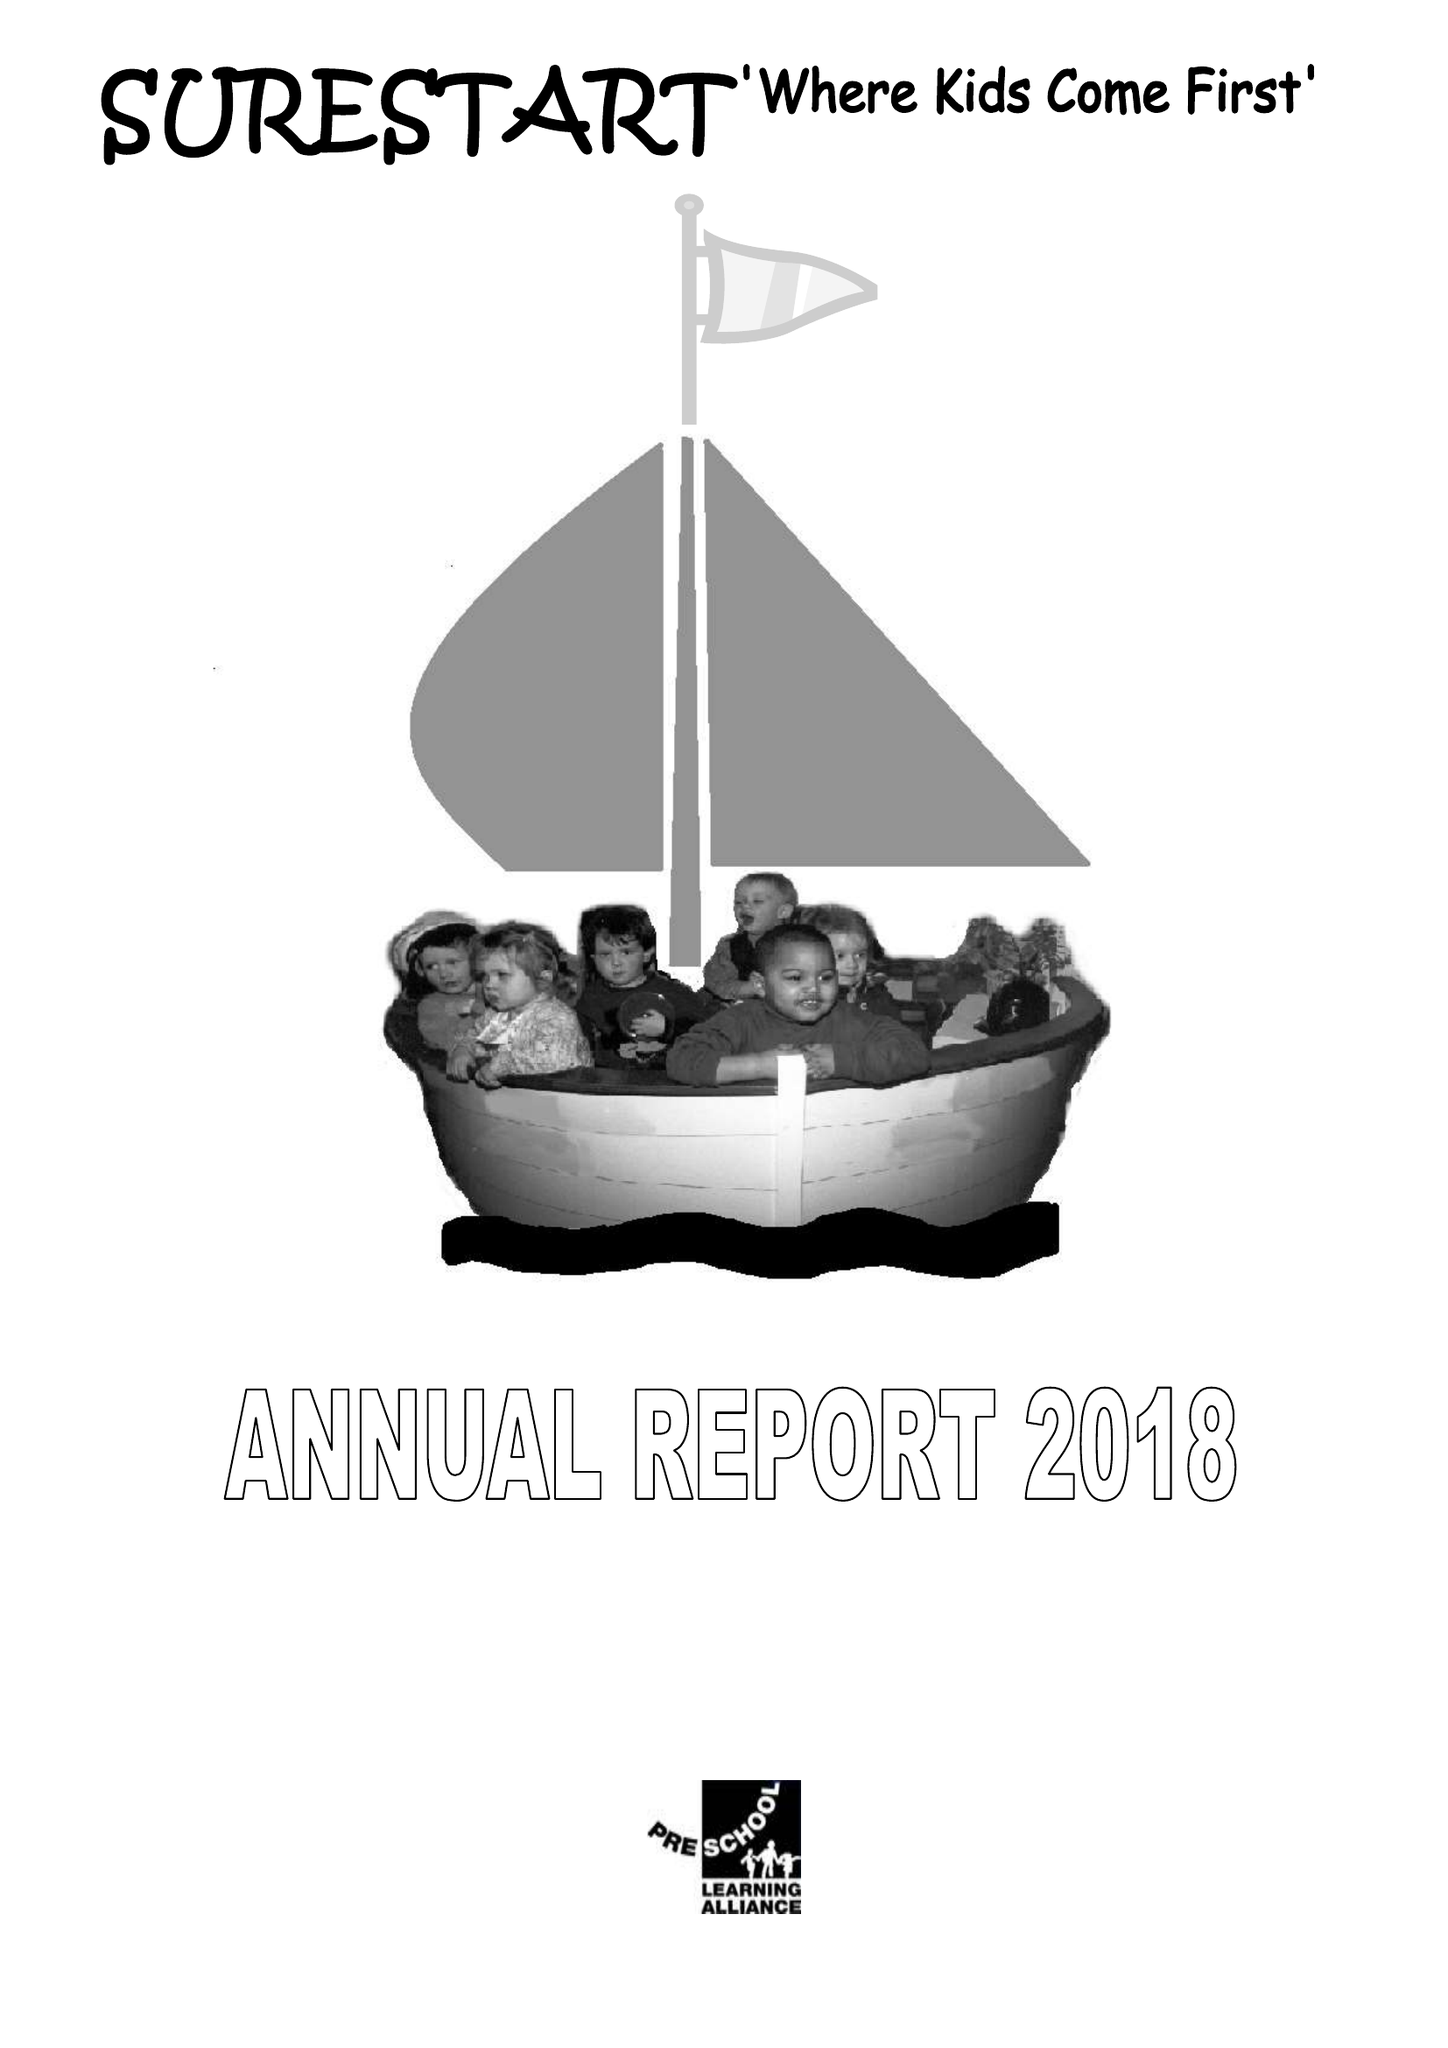What is the value for the charity_number?
Answer the question using a single word or phrase. 1064759 